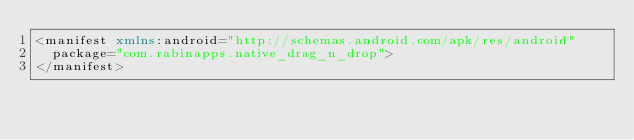Convert code to text. <code><loc_0><loc_0><loc_500><loc_500><_XML_><manifest xmlns:android="http://schemas.android.com/apk/res/android"
  package="com.rabinapps.native_drag_n_drop">
</manifest>
</code> 